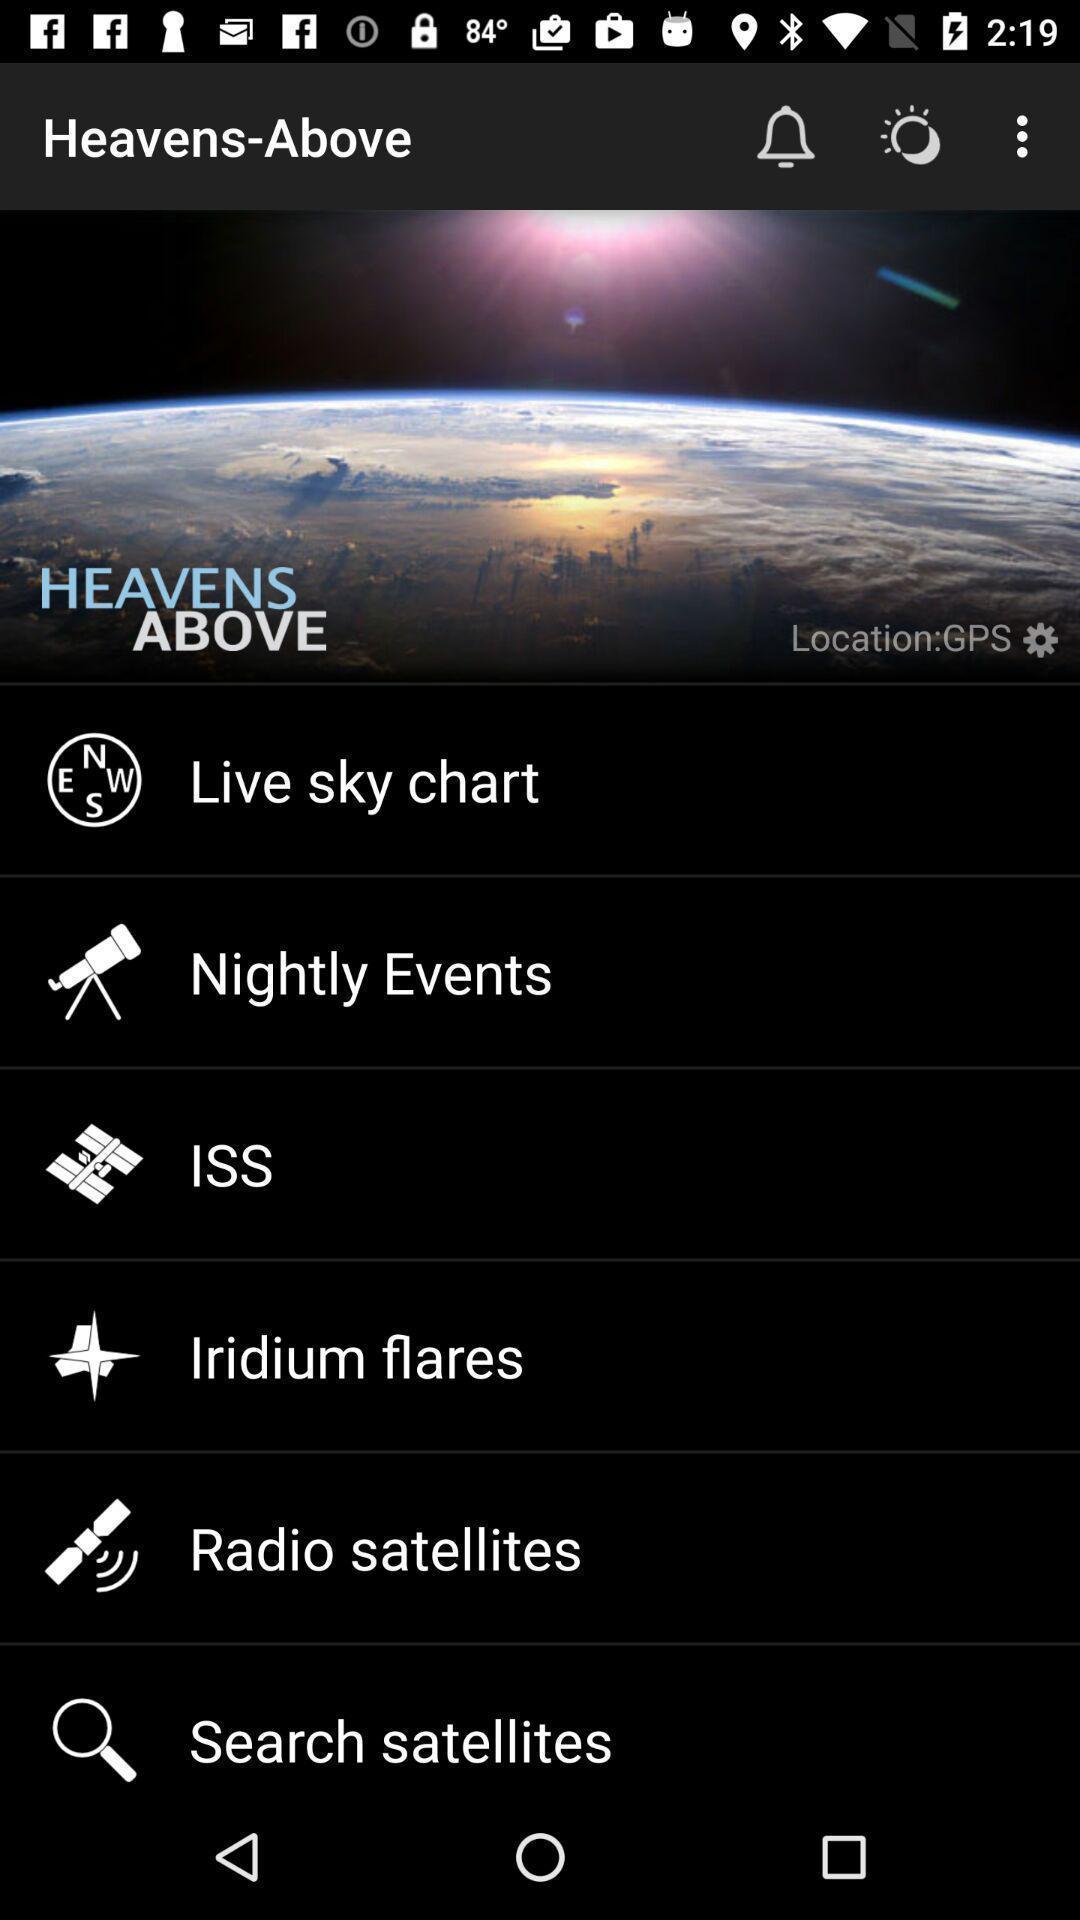Describe the key features of this screenshot. Page showing list of settings on a space app. 